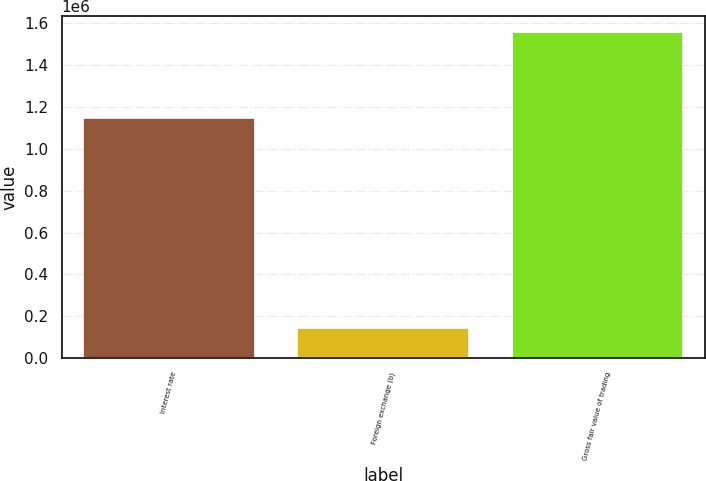<chart> <loc_0><loc_0><loc_500><loc_500><bar_chart><fcel>Interest rate<fcel>Foreign exchange (b)<fcel>Gross fair value of trading<nl><fcel>1.1489e+06<fcel>141790<fcel>1.55641e+06<nl></chart> 